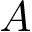<formula> <loc_0><loc_0><loc_500><loc_500>A</formula> 